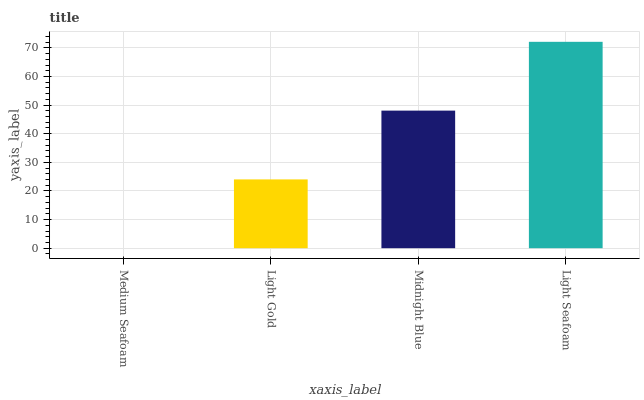Is Medium Seafoam the minimum?
Answer yes or no. Yes. Is Light Seafoam the maximum?
Answer yes or no. Yes. Is Light Gold the minimum?
Answer yes or no. No. Is Light Gold the maximum?
Answer yes or no. No. Is Light Gold greater than Medium Seafoam?
Answer yes or no. Yes. Is Medium Seafoam less than Light Gold?
Answer yes or no. Yes. Is Medium Seafoam greater than Light Gold?
Answer yes or no. No. Is Light Gold less than Medium Seafoam?
Answer yes or no. No. Is Midnight Blue the high median?
Answer yes or no. Yes. Is Light Gold the low median?
Answer yes or no. Yes. Is Medium Seafoam the high median?
Answer yes or no. No. Is Light Seafoam the low median?
Answer yes or no. No. 